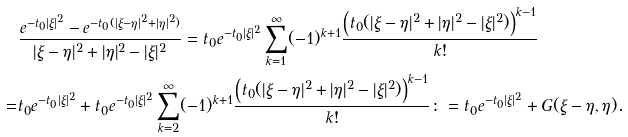Convert formula to latex. <formula><loc_0><loc_0><loc_500><loc_500>& \frac { e ^ { - t _ { 0 } | \xi | ^ { 2 } } - e ^ { - t _ { 0 } ( | \xi - \eta | ^ { 2 } + | \eta | ^ { 2 } ) } } { | \xi - \eta | ^ { 2 } + | \eta | ^ { 2 } - | \xi | ^ { 2 } } = t _ { 0 } e ^ { - t _ { 0 } | \xi | ^ { 2 } } \sum _ { k = 1 } ^ { \infty } ( - 1 ) ^ { k + 1 } \frac { \left ( t _ { 0 } ( | \xi - \eta | ^ { 2 } + | \eta | ^ { 2 } - | \xi | ^ { 2 } ) \right ) ^ { k - 1 } } { k ! } \\ = & t _ { 0 } e ^ { - t _ { 0 } | \xi | ^ { 2 } } + t _ { 0 } e ^ { - t _ { 0 } | \xi | ^ { 2 } } \sum _ { k = 2 } ^ { \infty } ( - 1 ) ^ { k + 1 } \frac { \left ( t _ { 0 } ( | \xi - \eta | ^ { 2 } + | \eta | ^ { 2 } - | \xi | ^ { 2 } ) \right ) ^ { k - 1 } } { k ! } \colon = t _ { 0 } e ^ { - t _ { 0 } | \xi | ^ { 2 } } + G ( \xi - \eta , \eta ) .</formula> 